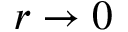<formula> <loc_0><loc_0><loc_500><loc_500>r \rightarrow 0</formula> 